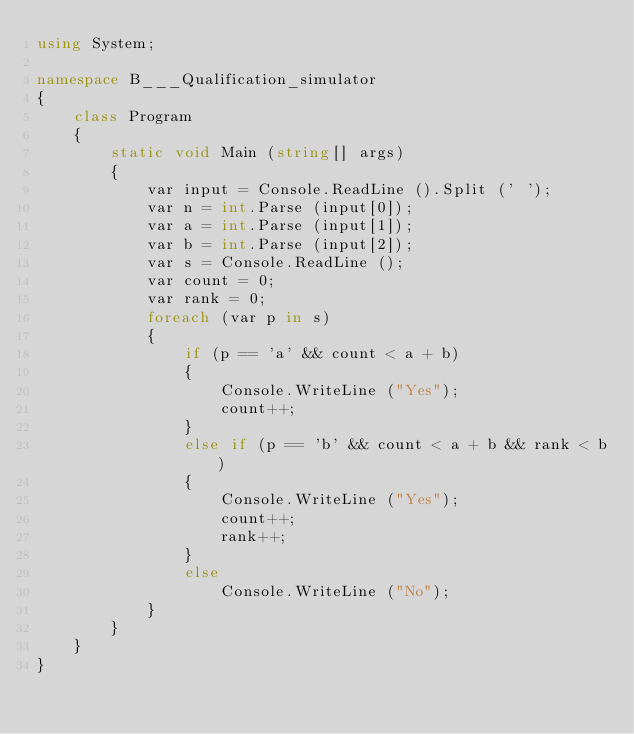<code> <loc_0><loc_0><loc_500><loc_500><_C#_>using System;

namespace B___Qualification_simulator
{
    class Program
    {
        static void Main (string[] args)
        {
            var input = Console.ReadLine ().Split (' ');
            var n = int.Parse (input[0]);
            var a = int.Parse (input[1]);
            var b = int.Parse (input[2]);
            var s = Console.ReadLine ();
            var count = 0;
            var rank = 0;
            foreach (var p in s)
            {
                if (p == 'a' && count < a + b)
                {
                    Console.WriteLine ("Yes");
                    count++;
                }
                else if (p == 'b' && count < a + b && rank < b)
                {
                    Console.WriteLine ("Yes");
                    count++;
                    rank++;
                }
                else
                    Console.WriteLine ("No");
            }
        }
    }
}</code> 